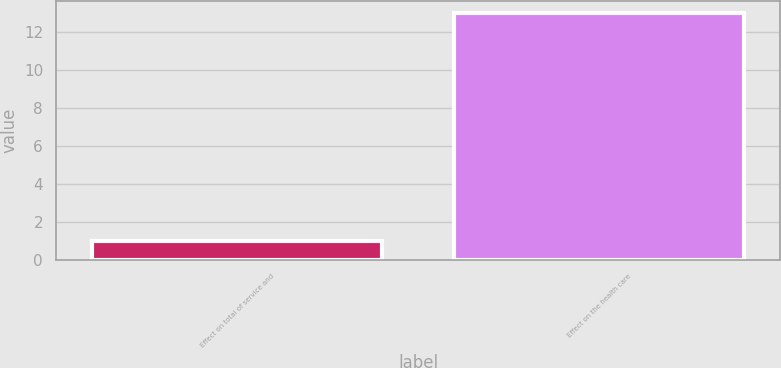Convert chart. <chart><loc_0><loc_0><loc_500><loc_500><bar_chart><fcel>Effect on total of service and<fcel>Effect on the health care<nl><fcel>1<fcel>13<nl></chart> 